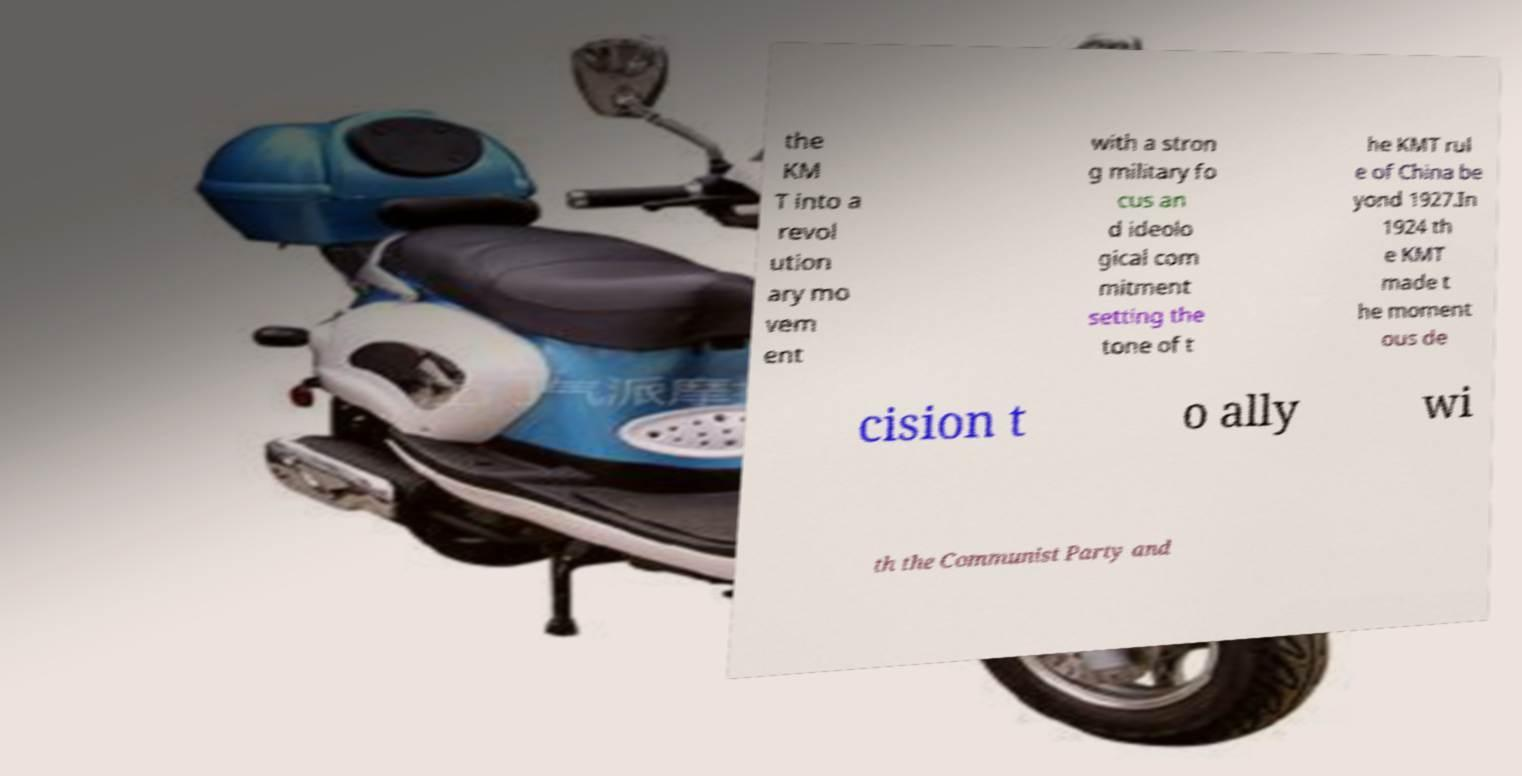Please read and relay the text visible in this image. What does it say? the KM T into a revol ution ary mo vem ent with a stron g military fo cus an d ideolo gical com mitment setting the tone of t he KMT rul e of China be yond 1927.In 1924 th e KMT made t he moment ous de cision t o ally wi th the Communist Party and 